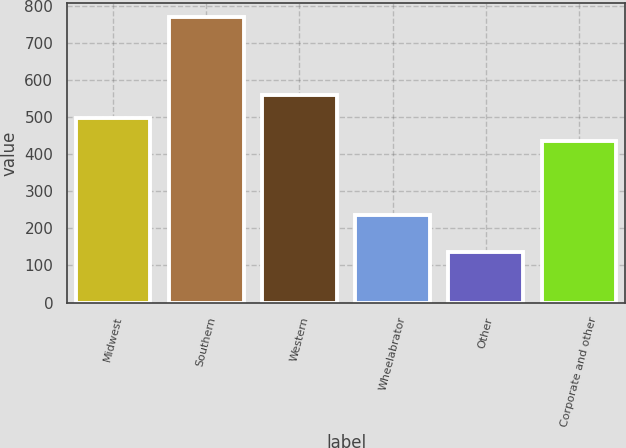Convert chart to OTSL. <chart><loc_0><loc_0><loc_500><loc_500><bar_chart><fcel>Midwest<fcel>Southern<fcel>Western<fcel>Wheelabrator<fcel>Other<fcel>Corporate and other<nl><fcel>497.2<fcel>768<fcel>560.4<fcel>235<fcel>136<fcel>434<nl></chart> 